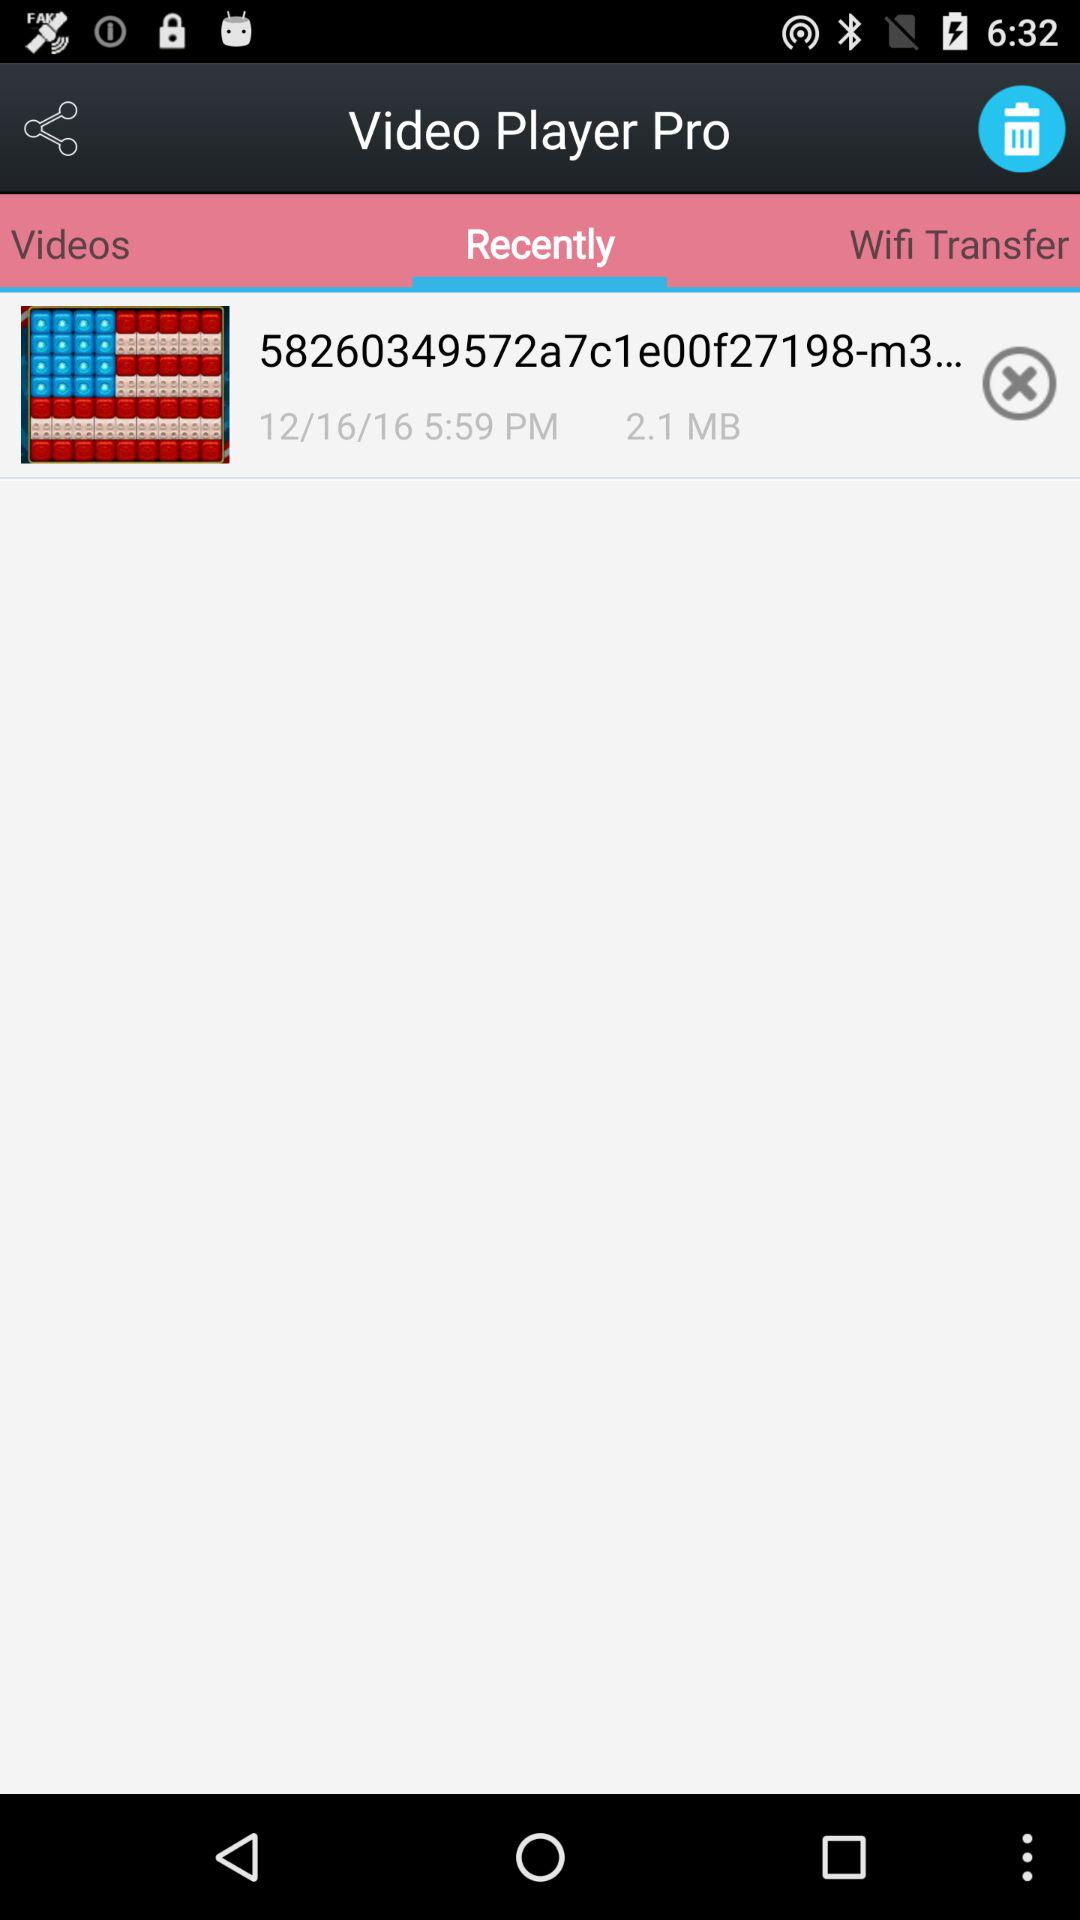What's the total storage of the video? The total storage is 2.1 MB. 